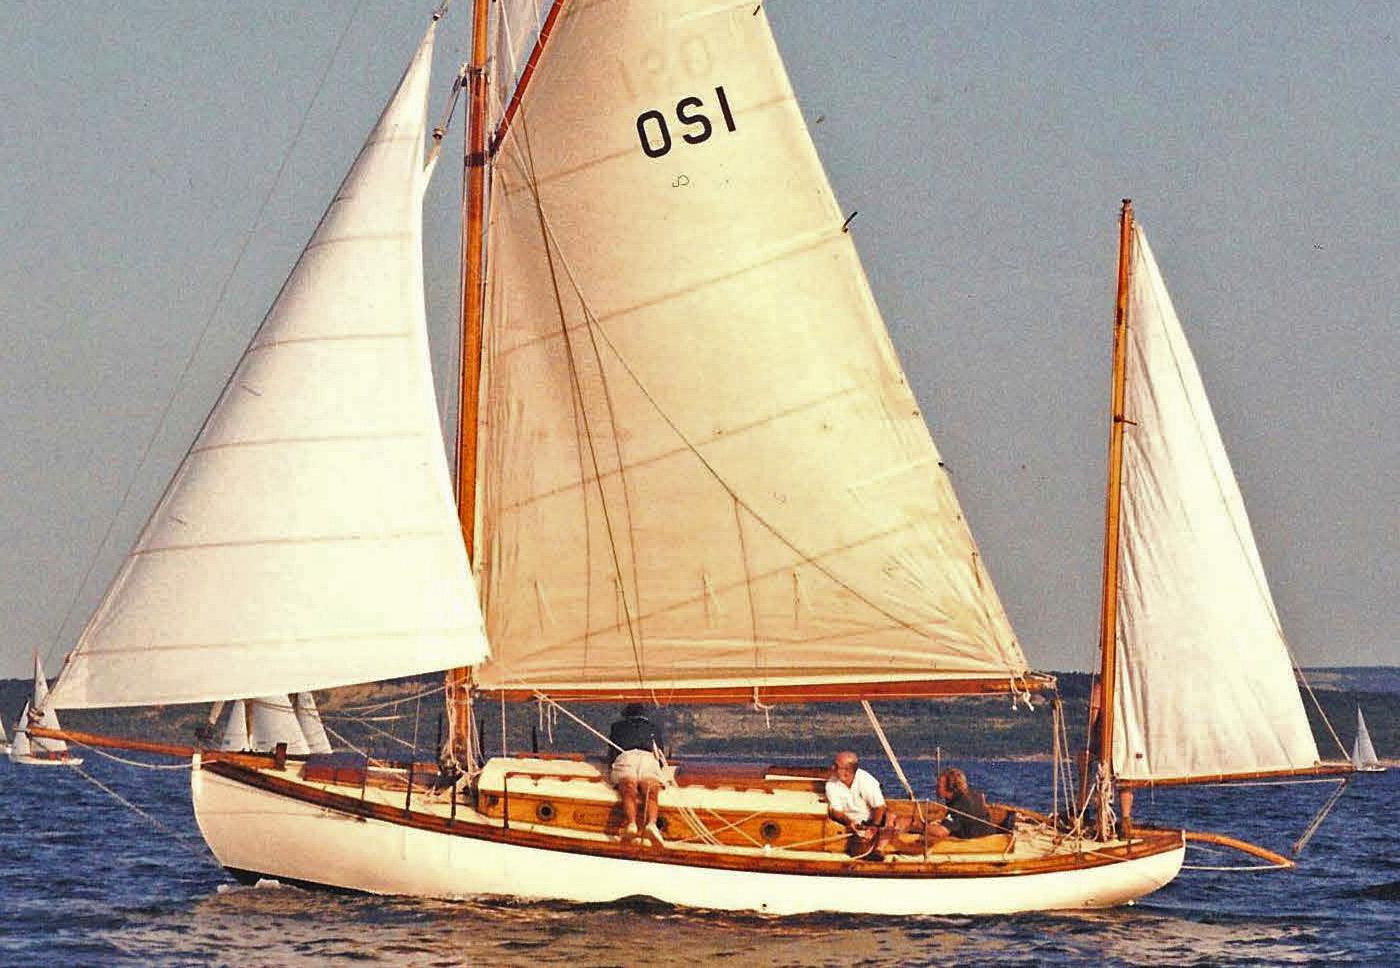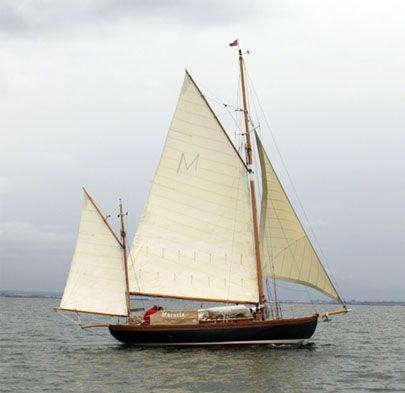The first image is the image on the left, the second image is the image on the right. Given the left and right images, does the statement "One of the images contains at least one sailboat with no raised sails." hold true? Answer yes or no. No. 